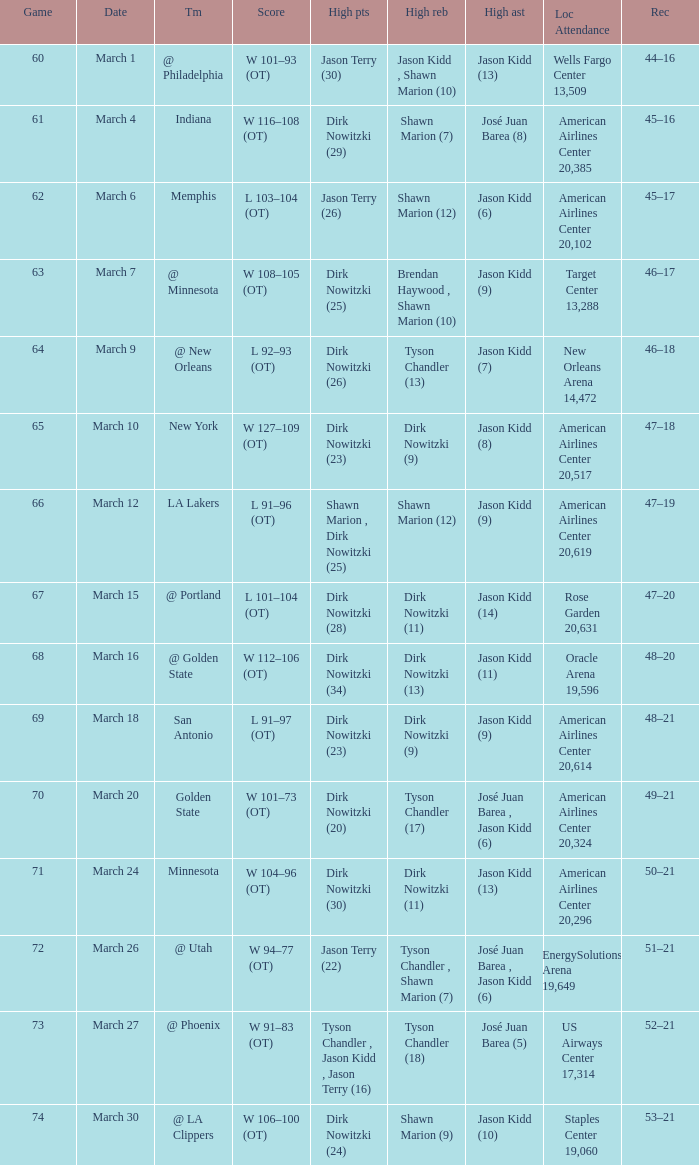Name the high assists for  l 103–104 (ot) Jason Kidd (6). 